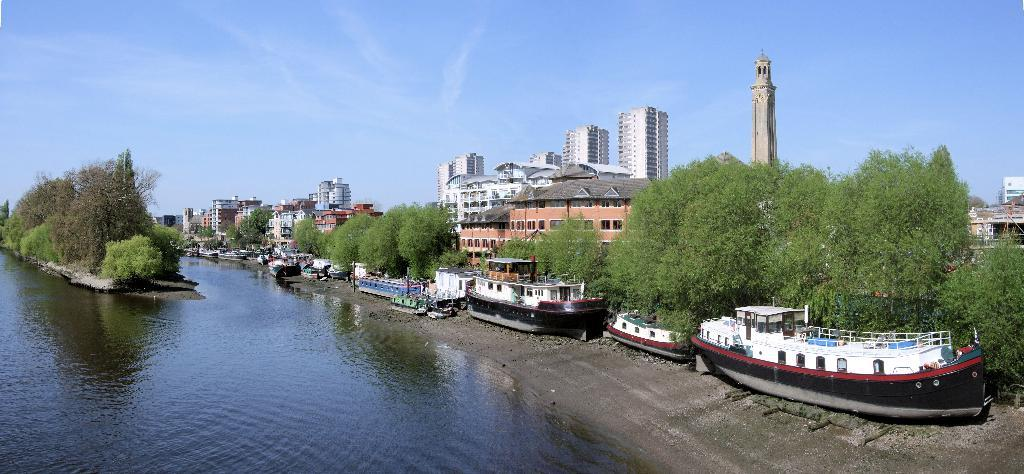What is one of the natural elements visible in the image? There is water visible in the image. What type of vegetation can be seen in the image? There are trees in the image. What types of watercraft are present in the image? There are ships and boats in the image. What architectural features can be observed on the buildings in the image? There are buildings with windows in the image. What color is the sock hanging from the tree in the image? There is no sock present in the image; it only features water, trees, ships, boats, and buildings. 